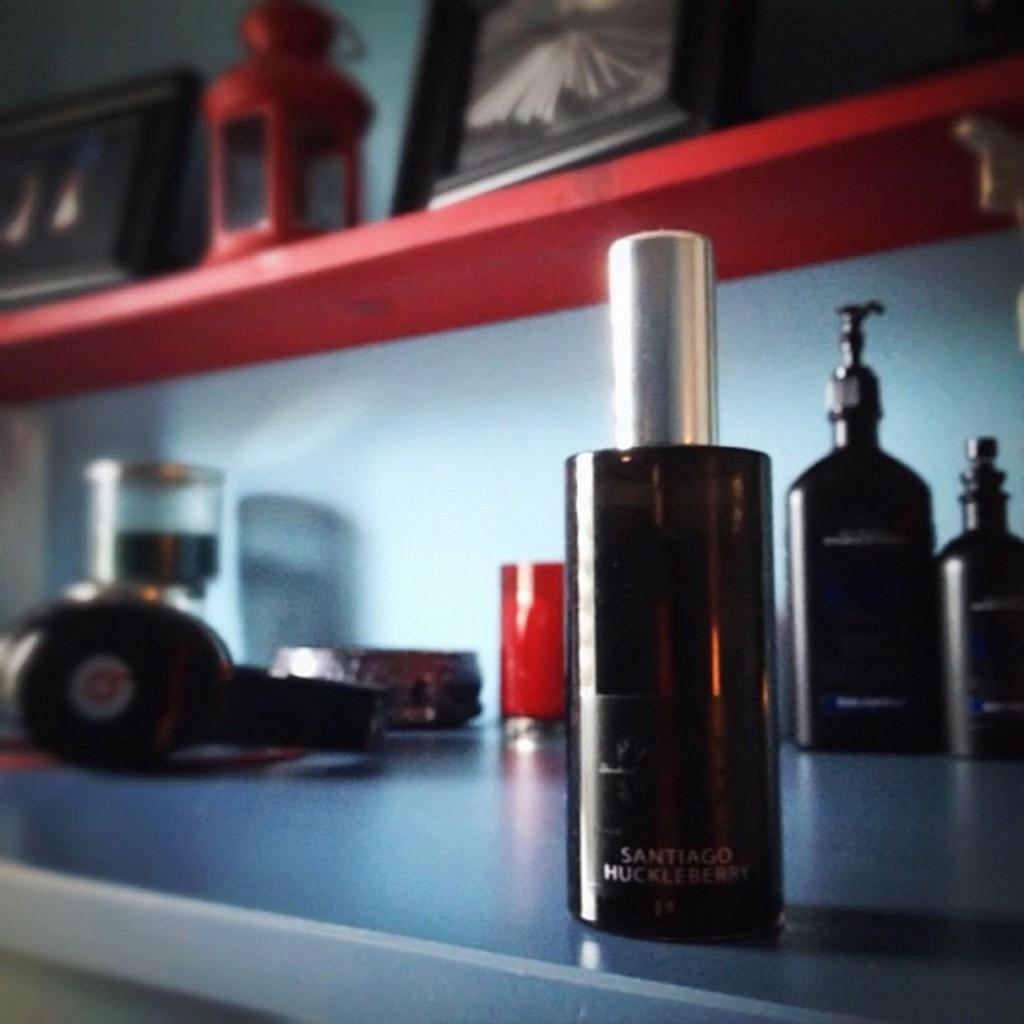What brand of headphones are those?
Keep it short and to the point. B. 